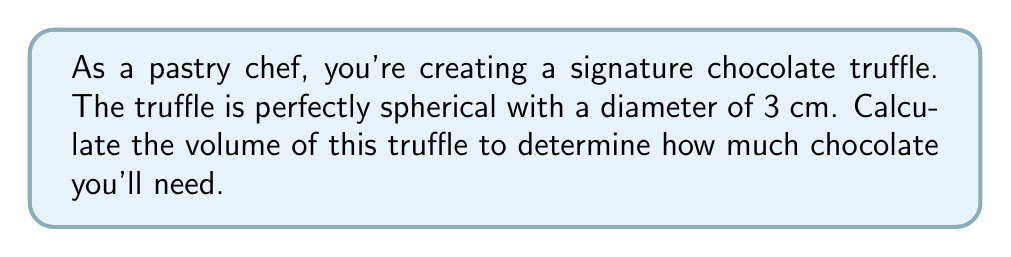Give your solution to this math problem. Let's approach this step-by-step:

1) The formula for the volume of a sphere is:

   $$V = \frac{4}{3}\pi r^3$$

   where $r$ is the radius of the sphere.

2) We're given the diameter of 3 cm. The radius is half of the diameter:

   $$r = \frac{3}{2} = 1.5 \text{ cm}$$

3) Now, let's substitute this into our volume formula:

   $$V = \frac{4}{3}\pi (1.5)^3$$

4) Let's calculate the cube of 1.5:

   $$(1.5)^3 = 1.5 \times 1.5 \times 1.5 = 3.375$$

5) Now our equation looks like:

   $$V = \frac{4}{3}\pi (3.375)$$

6) Multiply:

   $$V = 4.5\pi$$

7) Using $\pi \approx 3.14159$, we get:

   $$V \approx 4.5 \times 3.14159 \approx 14.13715 \text{ cm}^3$$

8) Rounding to two decimal places:

   $$V \approx 14.14 \text{ cm}^3$$

This volume represents the amount of chocolate needed to create your spherical truffle.
Answer: $14.14 \text{ cm}^3$ 